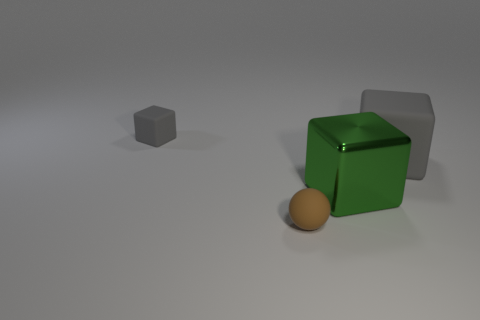What number of objects are gray objects on the left side of the brown sphere or small objects?
Offer a very short reply. 2. There is a gray object to the right of the gray rubber object that is to the left of the gray block that is to the right of the tiny rubber block; what is its size?
Give a very brief answer. Large. What is the material of the big object that is the same color as the small cube?
Ensure brevity in your answer.  Rubber. Are there any other things that have the same shape as the brown rubber object?
Give a very brief answer. No. There is a rubber sphere in front of the matte block behind the big gray matte object; what is its size?
Offer a terse response. Small. How many small objects are either red matte cylinders or metallic things?
Provide a succinct answer. 0. Are there fewer big objects than tiny green spheres?
Your response must be concise. No. Is the metallic cube the same color as the tiny rubber ball?
Provide a short and direct response. No. Are there more tiny gray things than gray blocks?
Your answer should be compact. No. What number of other objects are the same color as the tiny rubber cube?
Your response must be concise. 1. 